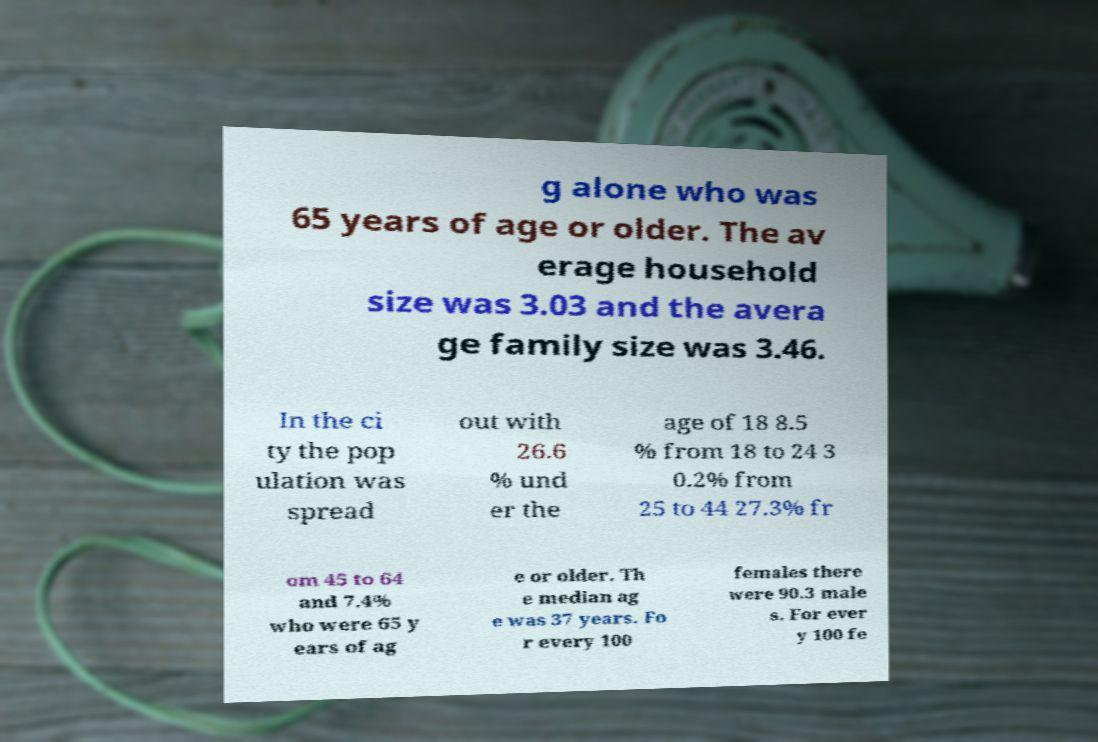Could you assist in decoding the text presented in this image and type it out clearly? g alone who was 65 years of age or older. The av erage household size was 3.03 and the avera ge family size was 3.46. In the ci ty the pop ulation was spread out with 26.6 % und er the age of 18 8.5 % from 18 to 24 3 0.2% from 25 to 44 27.3% fr om 45 to 64 and 7.4% who were 65 y ears of ag e or older. Th e median ag e was 37 years. Fo r every 100 females there were 90.3 male s. For ever y 100 fe 